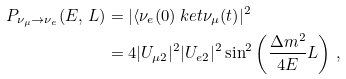Convert formula to latex. <formula><loc_0><loc_0><loc_500><loc_500>P _ { \nu _ { \mu } \rightarrow \nu _ { e } } ( E , \, L ) & = | \langle \nu _ { e } ( 0 ) \ k e t { \nu _ { \mu } ( t ) } | ^ { 2 } \\ & = 4 | U _ { \mu 2 } | ^ { 2 } | U _ { e 2 } | ^ { 2 } \sin ^ { 2 } \left ( \frac { \Delta m ^ { 2 } } { \, 4 E \, } L \right ) \, , \\</formula> 